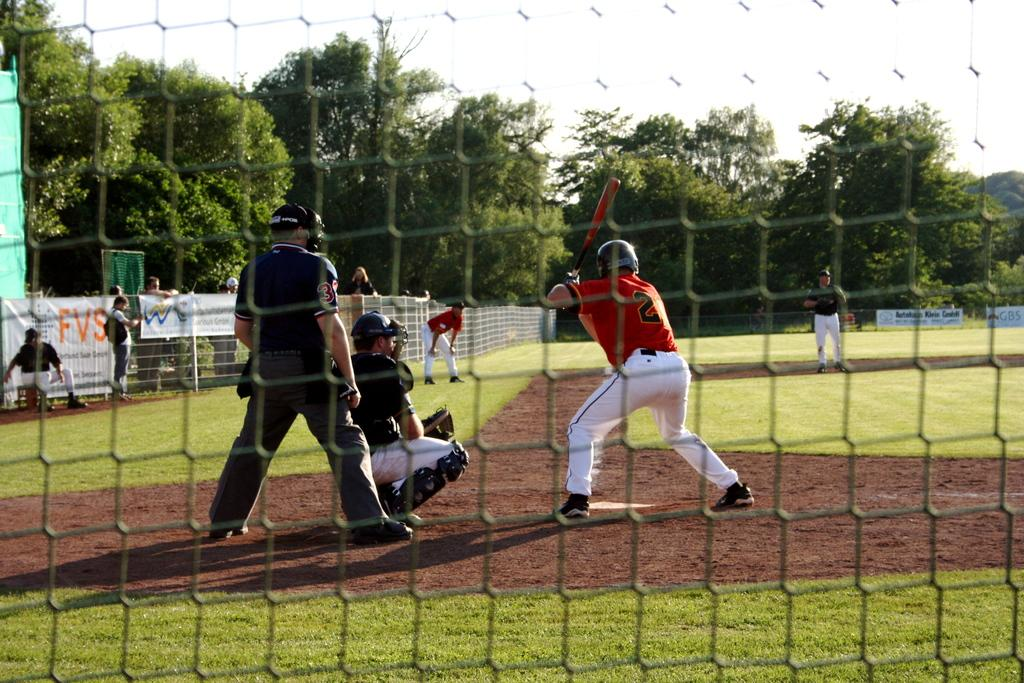<image>
Offer a succinct explanation of the picture presented. A baseball player, whose jersey number is 21, is at-bat. 